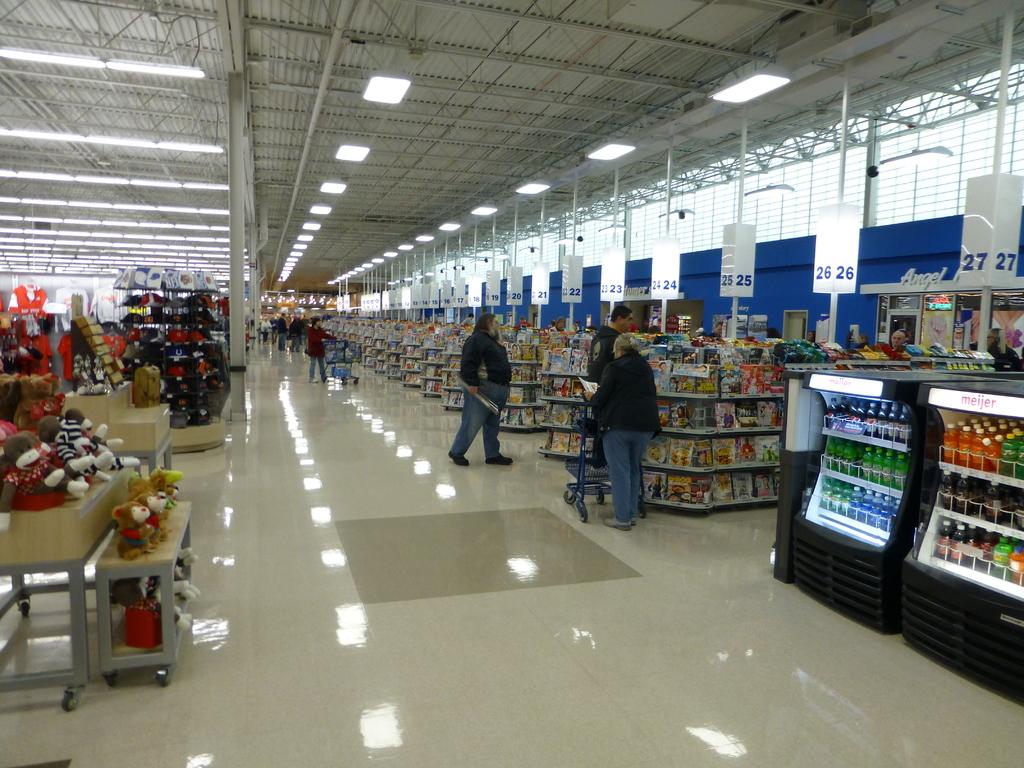What is the rightmost open lane?
Offer a terse response. 26. What brand is on the closest fridge?
Ensure brevity in your answer.  Meijer. 